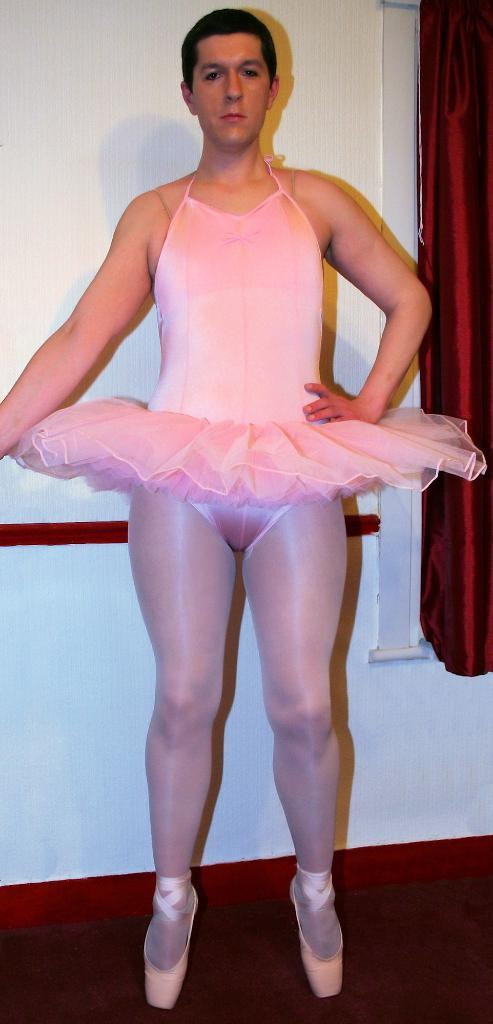What is the main subject of the image? There is a person standing in the image. What can be seen on the window in the image? There is a curtain on the window in the image. What is located beside the window in the image? There is a wall beside the window in the image. How many chickens are visible in the image? There are no chickens present in the image. What type of club is the person holding in the image? There is no club visible in the image; the person is not holding anything. 